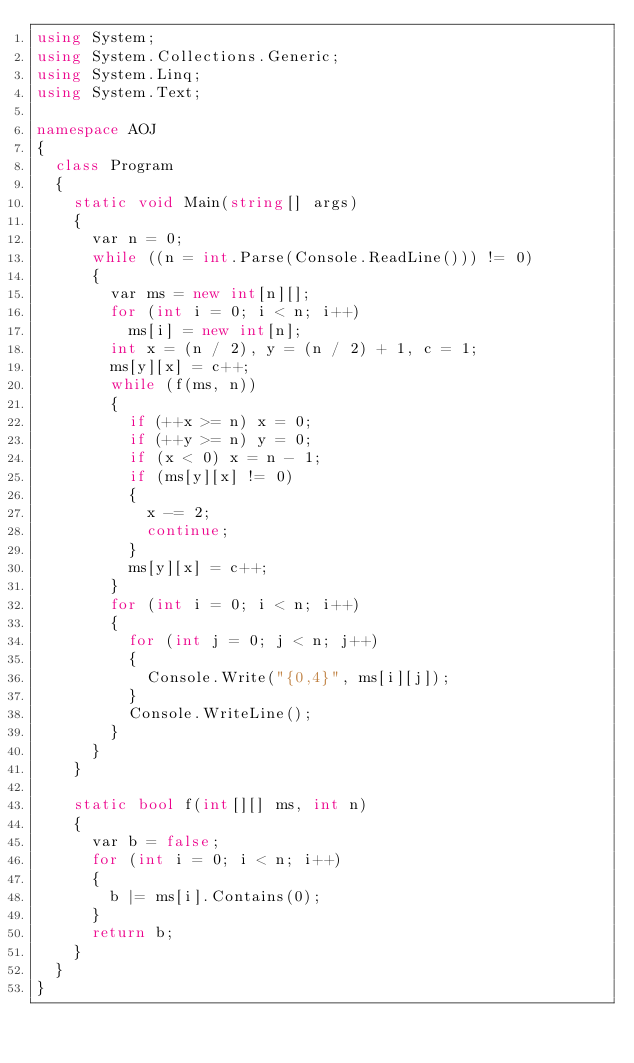Convert code to text. <code><loc_0><loc_0><loc_500><loc_500><_C#_>using System;
using System.Collections.Generic;
using System.Linq;
using System.Text;

namespace AOJ
{
	class Program
	{
		static void Main(string[] args)
		{
			var n = 0;
			while ((n = int.Parse(Console.ReadLine())) != 0)
			{
				var ms = new int[n][];
				for (int i = 0; i < n; i++)
					ms[i] = new int[n];
				int x = (n / 2), y = (n / 2) + 1, c = 1;
				ms[y][x] = c++;
				while (f(ms, n))
				{
					if (++x >= n) x = 0;
					if (++y >= n) y = 0;
					if (x < 0) x = n - 1;
					if (ms[y][x] != 0)
					{
						x -= 2;
						continue;
					}
					ms[y][x] = c++;
				}
				for (int i = 0; i < n; i++)
				{
					for (int j = 0; j < n; j++)
					{
						Console.Write("{0,4}", ms[i][j]);
					}
					Console.WriteLine();
				}
			}
		}

		static bool f(int[][] ms, int n)
		{
			var b = false;
			for (int i = 0; i < n; i++)
			{
				b |= ms[i].Contains(0);
			}
			return b;
		}
	}
}</code> 